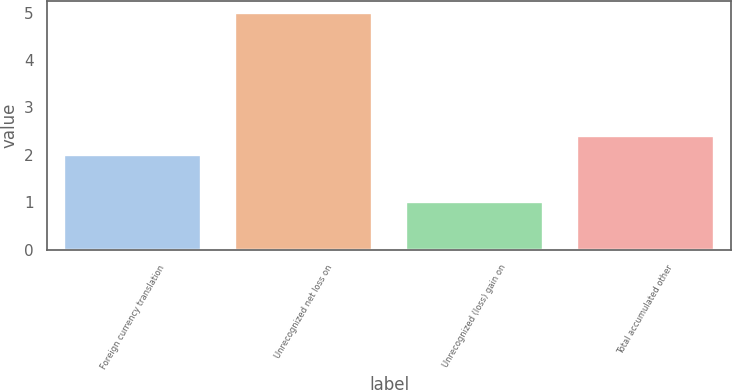<chart> <loc_0><loc_0><loc_500><loc_500><bar_chart><fcel>Foreign currency translation<fcel>Unrecognized net loss on<fcel>Unrecognized (loss) gain on<fcel>Total accumulated other<nl><fcel>2<fcel>5<fcel>1<fcel>2.4<nl></chart> 